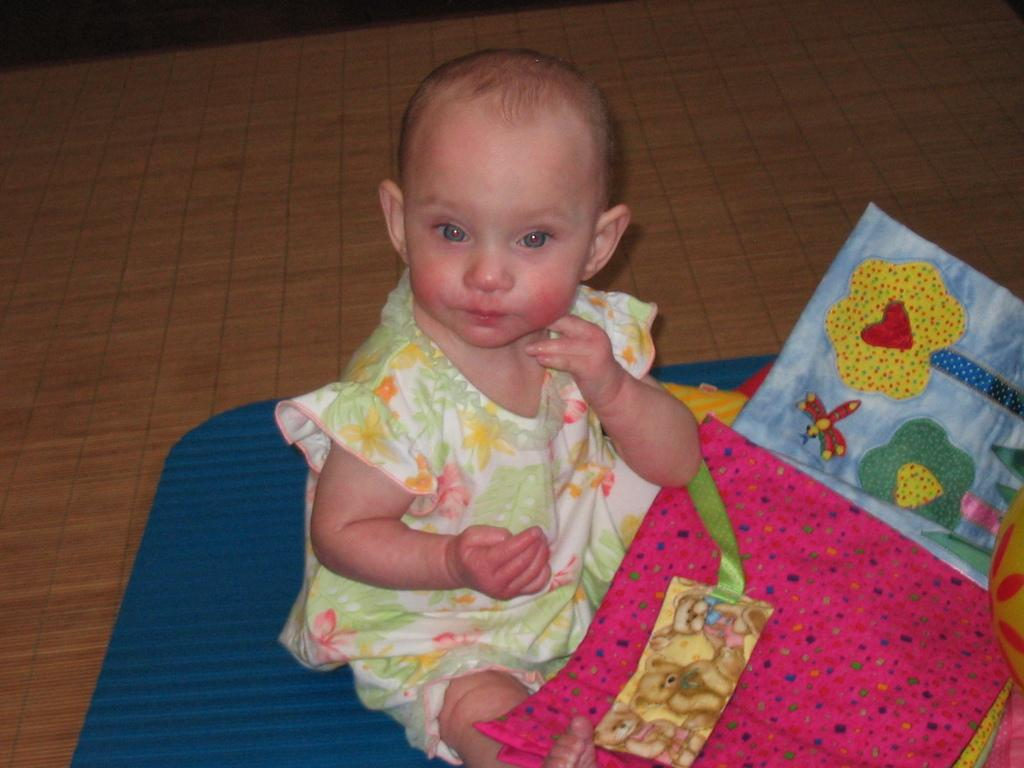What is the girl in the image doing? The girl is sitting in the image. What can be seen at the bottom of the image? There are clothes visible at the bottom of the image. What is located on the right side of the image? There is an object on the right side of the image. What material is the floor made of in the image? The floor in the image is made of wood. What type of plant is the girl reading in the image? There is no plant or reading activity present in the image. 